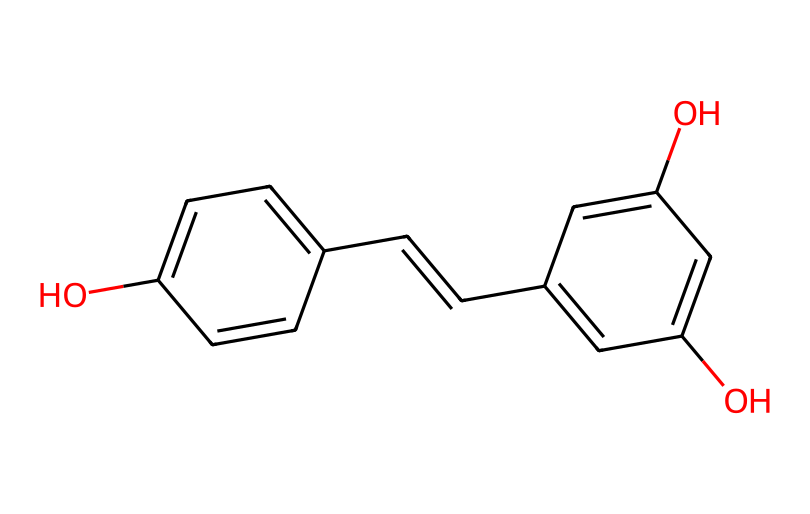What is the molecular formula of resveratrol? The molecular formula can be derived from the chemical structure by counting the number of carbon (C), hydrogen (H), and oxygen (O) atoms present. In this case, the structure has 14 carbon atoms, 12 hydrogen atoms, and 4 oxygen atoms. Therefore, the molecular formula is C14H12O4.
Answer: C14H12O4 How many hydroxyl (–OH) groups are present in the chemical structure? The hydroxyl groups are identified by the presence of the –OH functional groups. In this structure, there are three hydroxyl groups attached to the phenolic rings.
Answer: 3 What type of chemical compound is resveratrol? Resveratrol is classified as a polyphenol, which is a type of antioxidant characterized by the presence of multiple phenolic structures. The presence of multiple aromatic rings and hydroxyl groups defines this classification.
Answer: polyphenol Which part of the structure contributes to its antioxidant properties? Antioxidant properties in resveratrol are largely attributed to the hydroxyl groups that can donate electrons and neutralize free radicals. The presence of these functional groups allows resveratrol to be effective in combating oxidative stress.
Answer: hydroxyl groups What is the number of rings in the resveratrol structure? The resveratrol structure contains two aromatic rings that are linked by a double bond. By closely analyzing the structure, we can observe these two distinct ring systems.
Answer: 2 